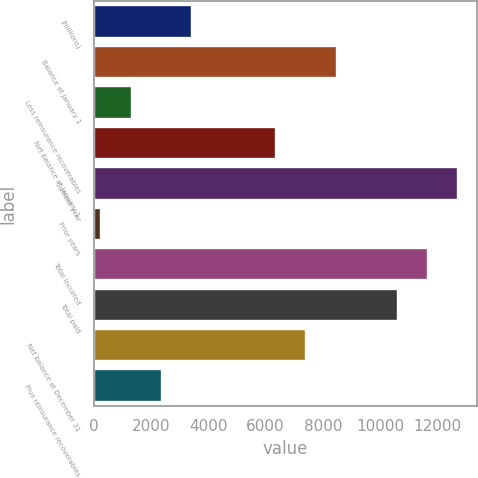Convert chart. <chart><loc_0><loc_0><loc_500><loc_500><bar_chart><fcel>(millions)<fcel>Balance at January 1<fcel>Less reinsurance recoverables<fcel>Net balance at January 1<fcel>Current year<fcel>Prior years<fcel>Total incurred<fcel>Total paid<fcel>Net balance at December 31<fcel>Plus reinsurance recoverables<nl><fcel>3432.44<fcel>8493.86<fcel>1305.48<fcel>6366.9<fcel>12747.8<fcel>242<fcel>11684.3<fcel>10620.8<fcel>7430.38<fcel>2368.96<nl></chart> 